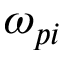Convert formula to latex. <formula><loc_0><loc_0><loc_500><loc_500>\omega _ { p i }</formula> 